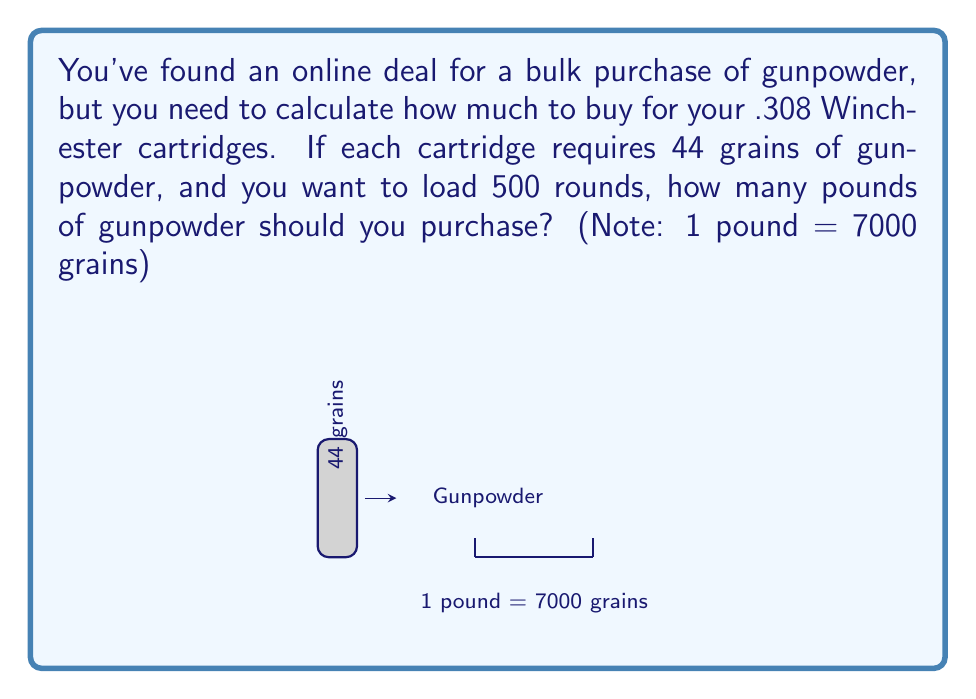Can you solve this math problem? Let's break this problem down step-by-step:

1) First, we need to calculate the total amount of gunpowder needed for 500 rounds:
   $$500 \text{ rounds} \times 44 \text{ grains per round} = 22,000 \text{ grains}$$

2) Now, we need to convert this to pounds. We're given that 1 pound = 7000 grains.
   To convert from grains to pounds, we divide by 7000:

   $$\frac{22,000 \text{ grains}}{7000 \text{ grains/pound}} = \frac{22,000}{7000} \text{ pounds}$$

3) Let's simplify this fraction:
   $$\frac{22,000}{7000} = \frac{22}{7} = 3.142857... \text{ pounds}$$

4) Since we can't buy a fraction of a pound, we should round up to the nearest pound to ensure we have enough powder:
   $$3.142857... \text{ pounds} \approx 4 \text{ pounds}$$

Therefore, you should purchase 4 pounds of gunpowder to have enough for 500 rounds of .308 Winchester cartridges.
Answer: 4 pounds 